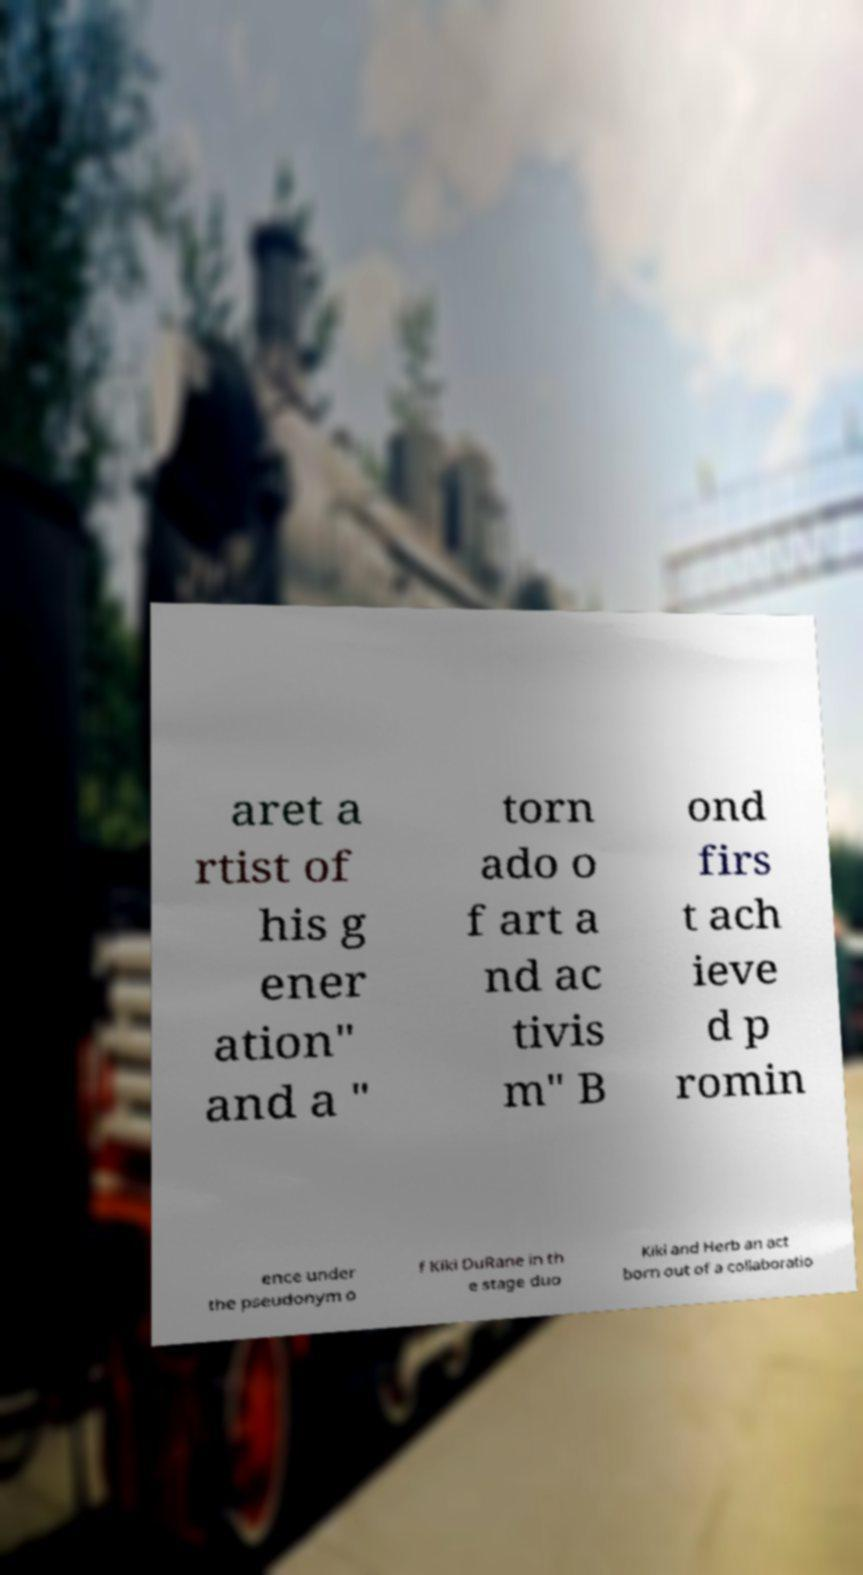Please read and relay the text visible in this image. What does it say? aret a rtist of his g ener ation" and a " torn ado o f art a nd ac tivis m" B ond firs t ach ieve d p romin ence under the pseudonym o f Kiki DuRane in th e stage duo Kiki and Herb an act born out of a collaboratio 